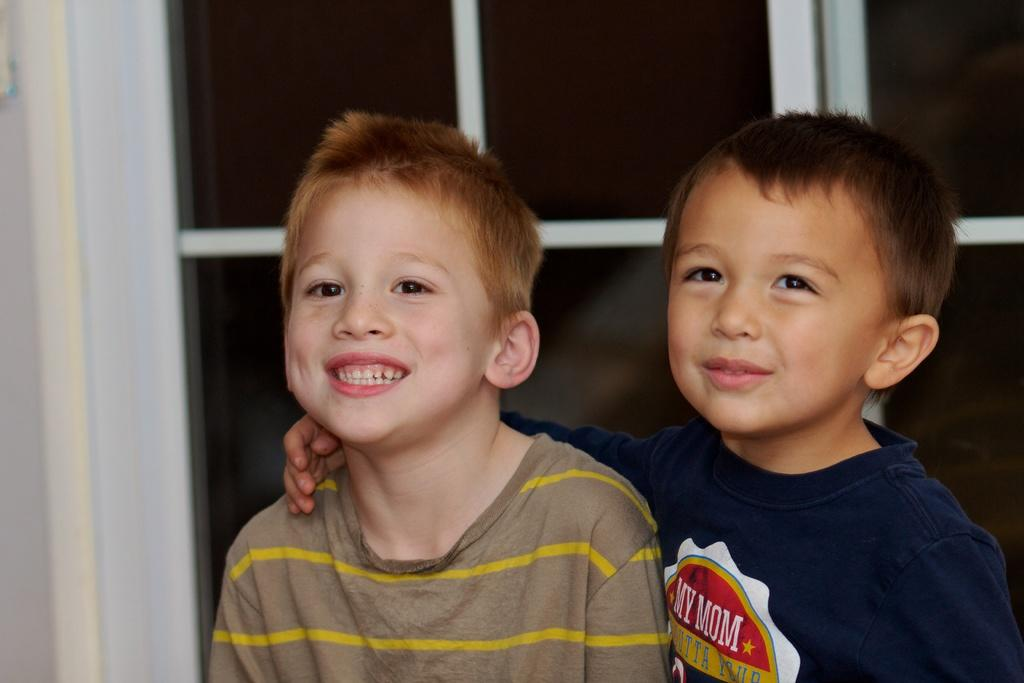How many people are in the image? There are two boys in the image. What can be seen behind the boys? The boys are in front of a door. What type of angle is being used to cut the sticks in the image? There are no sticks present in the image, so it is not possible to determine the type of angle being used to cut them. 